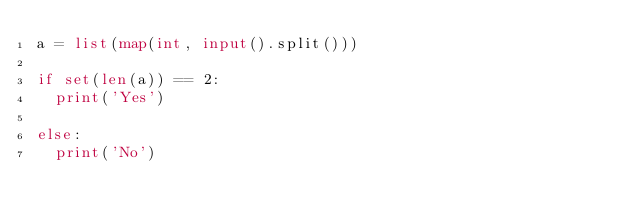Convert code to text. <code><loc_0><loc_0><loc_500><loc_500><_Python_>a = list(map(int, input().split()))

if set(len(a)) == 2:
  print('Yes')

else:
  print('No')
  
</code> 